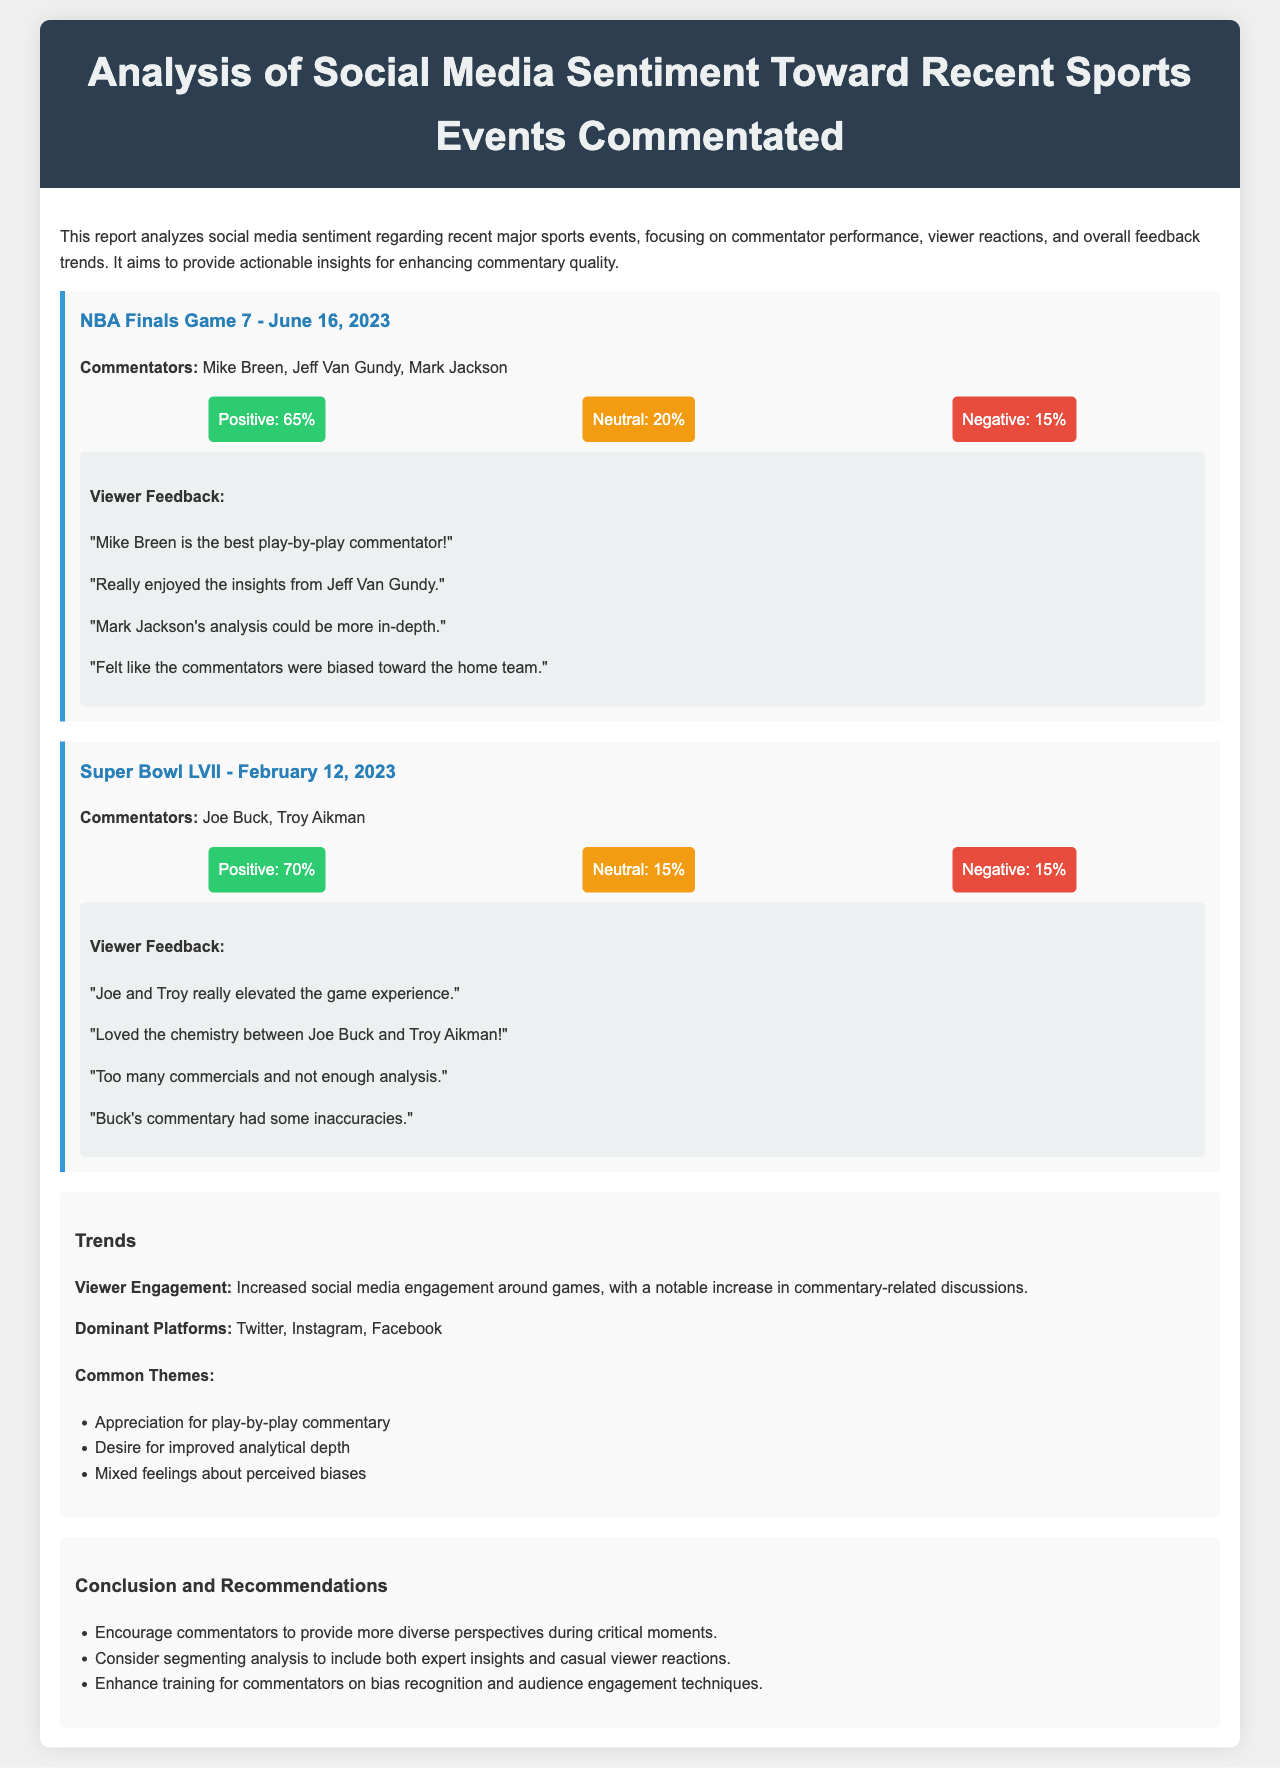What was the date of the NBA Finals Game 7? The document states that the NBA Finals Game 7 occurred on June 16, 2023.
Answer: June 16, 2023 Who were the commentators for Super Bowl LVII? The document lists Joe Buck and Troy Aikman as the commentators for Super Bowl LVII.
Answer: Joe Buck, Troy Aikman What percentage of viewers had a positive sentiment for the NBA Finals Game 7? The sentiment analysis shows that 65% of viewers had a positive sentiment for the NBA Finals Game 7.
Answer: 65% What common theme was mentioned regarding viewer feedback? One of the common themes mentioned is the appreciation for play-by-play commentary, found in the trends section.
Answer: Appreciation for play-by-play commentary What recommendation is made for commentators regarding biases? The conclusion suggests enhancing training for commentators on bias recognition.
Answer: Enhance training for commentators on bias recognition What was the sentiment percentage that was neutral for Super Bowl LVII? The document indicates that 15% of viewers had a neutral sentiment for Super Bowl LVII.
Answer: 15% Which social media platforms saw increased viewer engagement? The trends section mentions Twitter, Instagram, and Facebook as the dominant platforms for viewer engagement.
Answer: Twitter, Instagram, Facebook What feedback did viewers provide about Mark Jackson's analysis? Viewers commented that Mark Jackson's analysis could be more in-depth, as noted in the feedback section.
Answer: More in-depth What is the overall sentiment for commentators during the events analyzed? The sentiment analysis reflects a largely positive view toward the commentators with percentages varying between events but generally higher than neutral.
Answer: Largely positive 